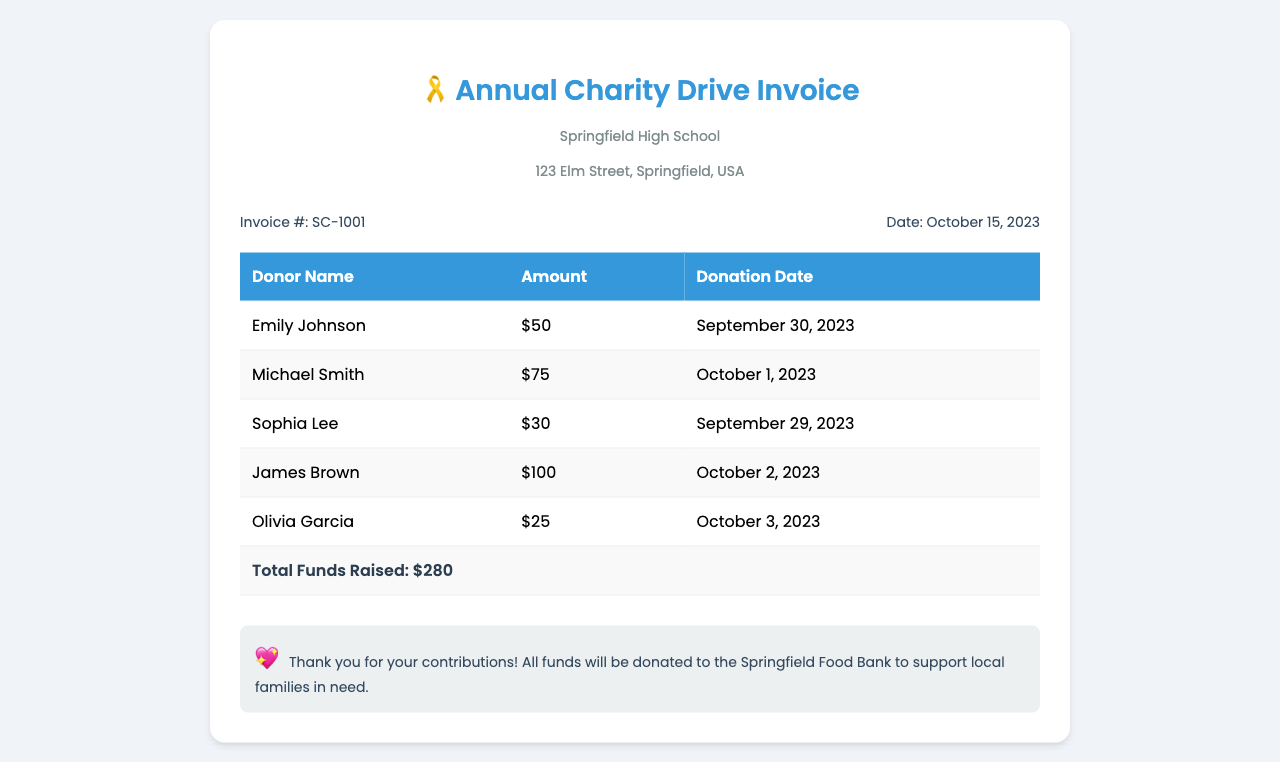What is the total amount raised? The total amount raised is the sum of all individual donations listed in the invoice, which totals $280.
Answer: $280 Who is the donor with the highest contribution? The donor with the highest contribution is the one listed with the maximum amount, which is James Brown with $100.
Answer: James Brown What is the invoice number? The invoice number is a unique identifier for this document, which is SC-1001.
Answer: SC-1001 How many donors contributed to the charity drive? The total number of donors is counted from the list provided in the invoice, which shows five donors.
Answer: 5 When was the invoice issued? The invoice was issued on a specific date mentioned in the document, which is October 15, 2023.
Answer: October 15, 2023 What is the donation date for Michael Smith? The donation date for Michael Smith is indicated next to his name in the document, which is October 1, 2023.
Answer: October 1, 2023 What organization will the raised funds be donated to? The organization that will receive the donations is explicitly stated in the notes at the bottom of the invoice, which is the Springfield Food Bank.
Answer: Springfield Food Bank How much did Olivia Garcia donate? The amount donated by Olivia Garcia is specified in the list, which is $25.
Answer: $25 